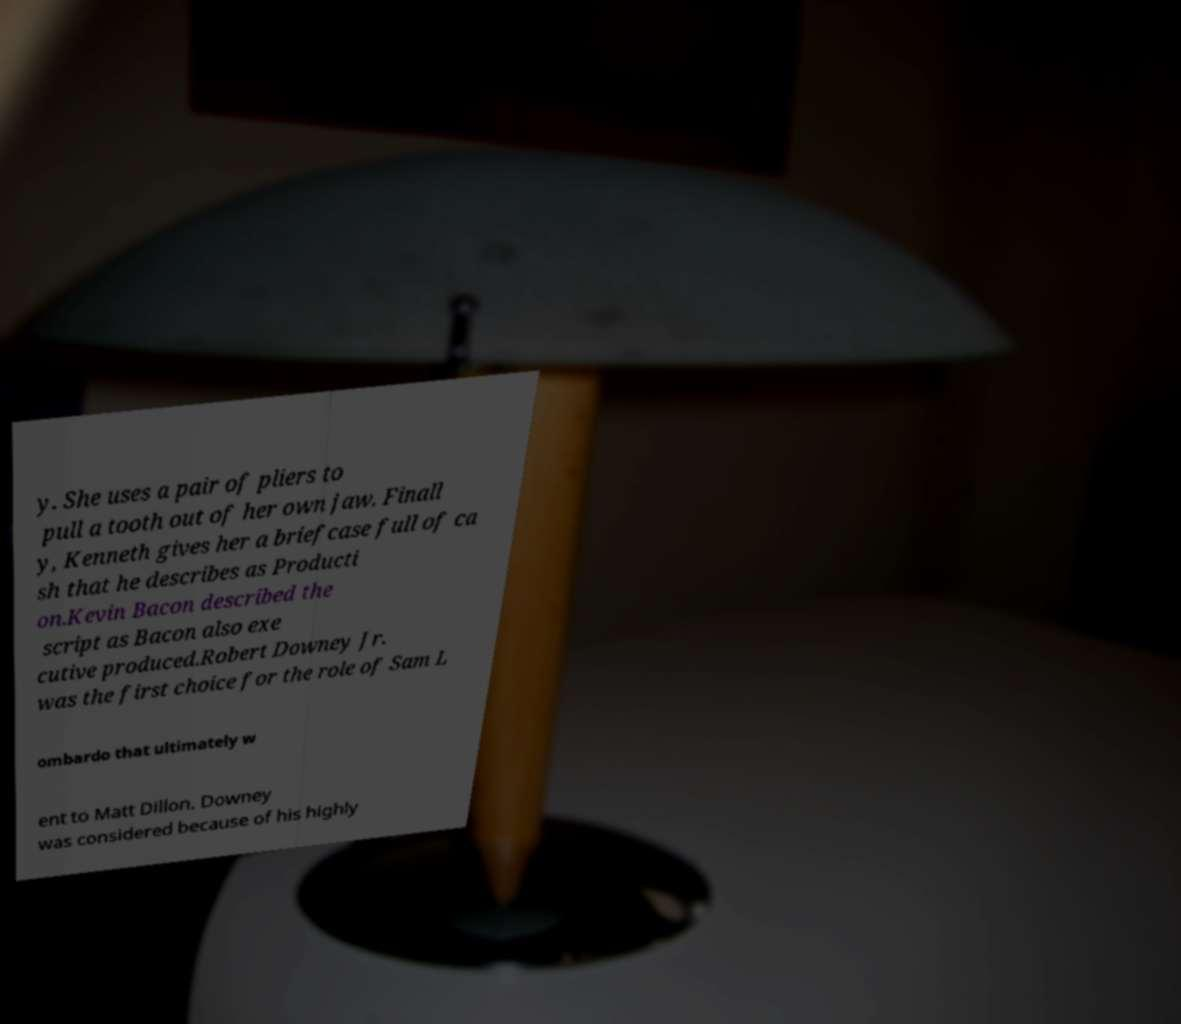There's text embedded in this image that I need extracted. Can you transcribe it verbatim? y. She uses a pair of pliers to pull a tooth out of her own jaw. Finall y, Kenneth gives her a briefcase full of ca sh that he describes as Producti on.Kevin Bacon described the script as Bacon also exe cutive produced.Robert Downey Jr. was the first choice for the role of Sam L ombardo that ultimately w ent to Matt Dillon. Downey was considered because of his highly 